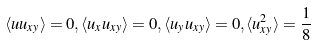<formula> <loc_0><loc_0><loc_500><loc_500>\langle u u _ { x y } \rangle = 0 , \langle u _ { x } u _ { x y } \rangle = 0 , \langle u _ { y } u _ { x y } \rangle = 0 , \langle u _ { x y } ^ { 2 } \rangle = \frac { 1 } { 8 }</formula> 